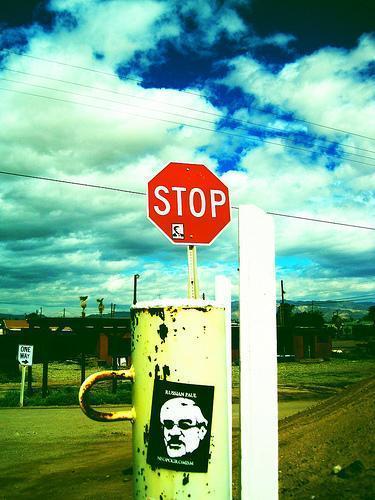How many stop signs do you see?
Give a very brief answer. 1. 